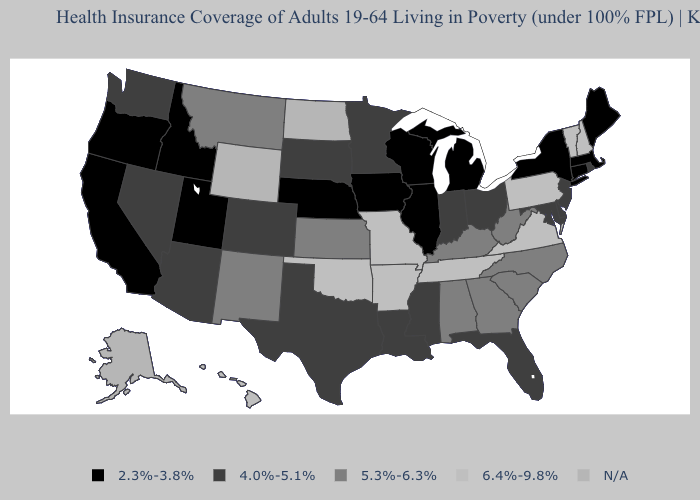Which states hav the highest value in the South?
Give a very brief answer. Arkansas, Oklahoma, Tennessee, Virginia. Does Florida have the lowest value in the South?
Write a very short answer. Yes. What is the value of New Mexico?
Concise answer only. 5.3%-6.3%. Among the states that border Washington , which have the lowest value?
Concise answer only. Idaho, Oregon. Among the states that border Alabama , does Florida have the lowest value?
Concise answer only. Yes. Among the states that border Montana , does Idaho have the lowest value?
Quick response, please. Yes. How many symbols are there in the legend?
Be succinct. 5. How many symbols are there in the legend?
Give a very brief answer. 5. Does Missouri have the highest value in the MidWest?
Concise answer only. Yes. Which states have the lowest value in the MidWest?
Keep it brief. Illinois, Iowa, Michigan, Nebraska, Wisconsin. Does the map have missing data?
Be succinct. Yes. What is the value of Colorado?
Write a very short answer. 4.0%-5.1%. Does Missouri have the highest value in the MidWest?
Answer briefly. Yes. What is the highest value in the USA?
Answer briefly. 6.4%-9.8%. 